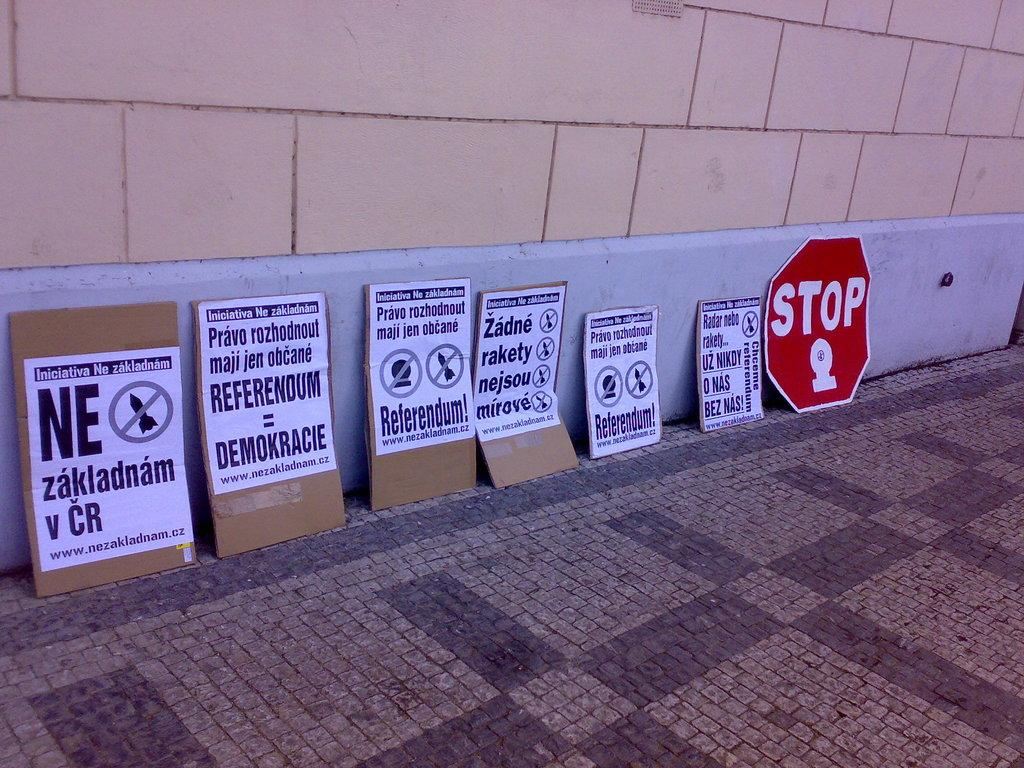<image>
Summarize the visual content of the image. The red sign at the end is a stop sign. 